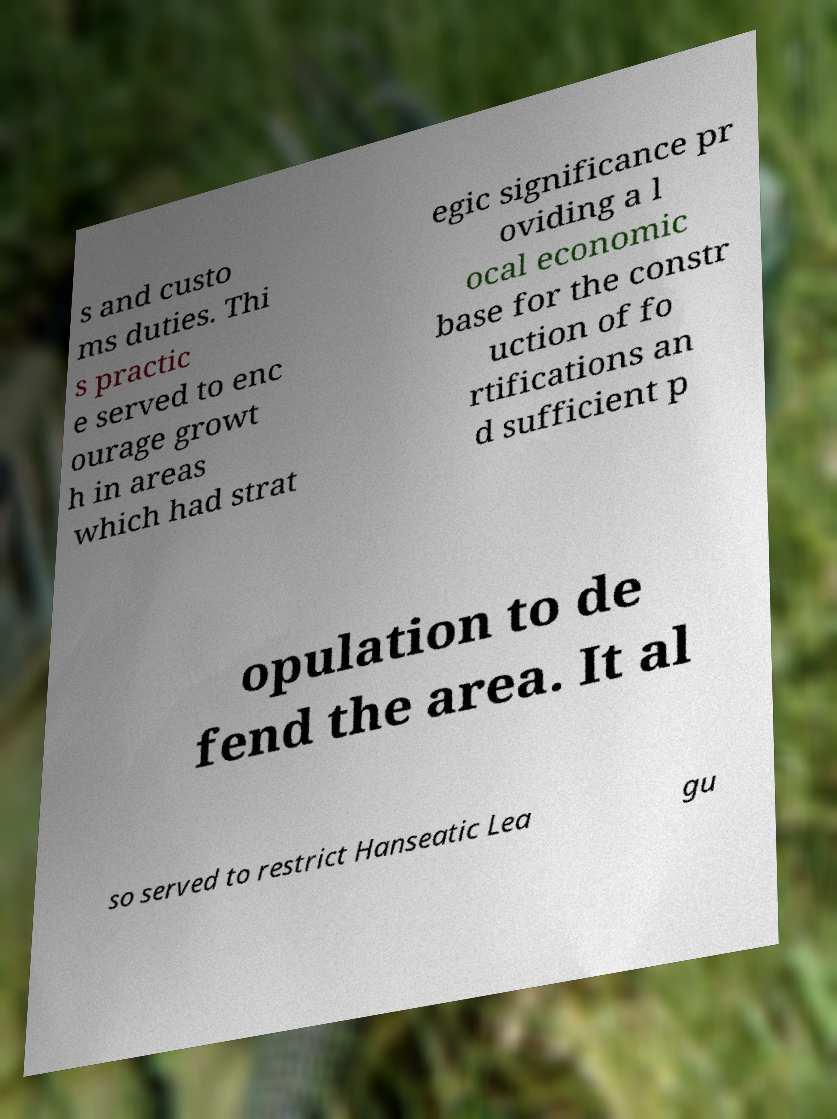I need the written content from this picture converted into text. Can you do that? s and custo ms duties. Thi s practic e served to enc ourage growt h in areas which had strat egic significance pr oviding a l ocal economic base for the constr uction of fo rtifications an d sufficient p opulation to de fend the area. It al so served to restrict Hanseatic Lea gu 